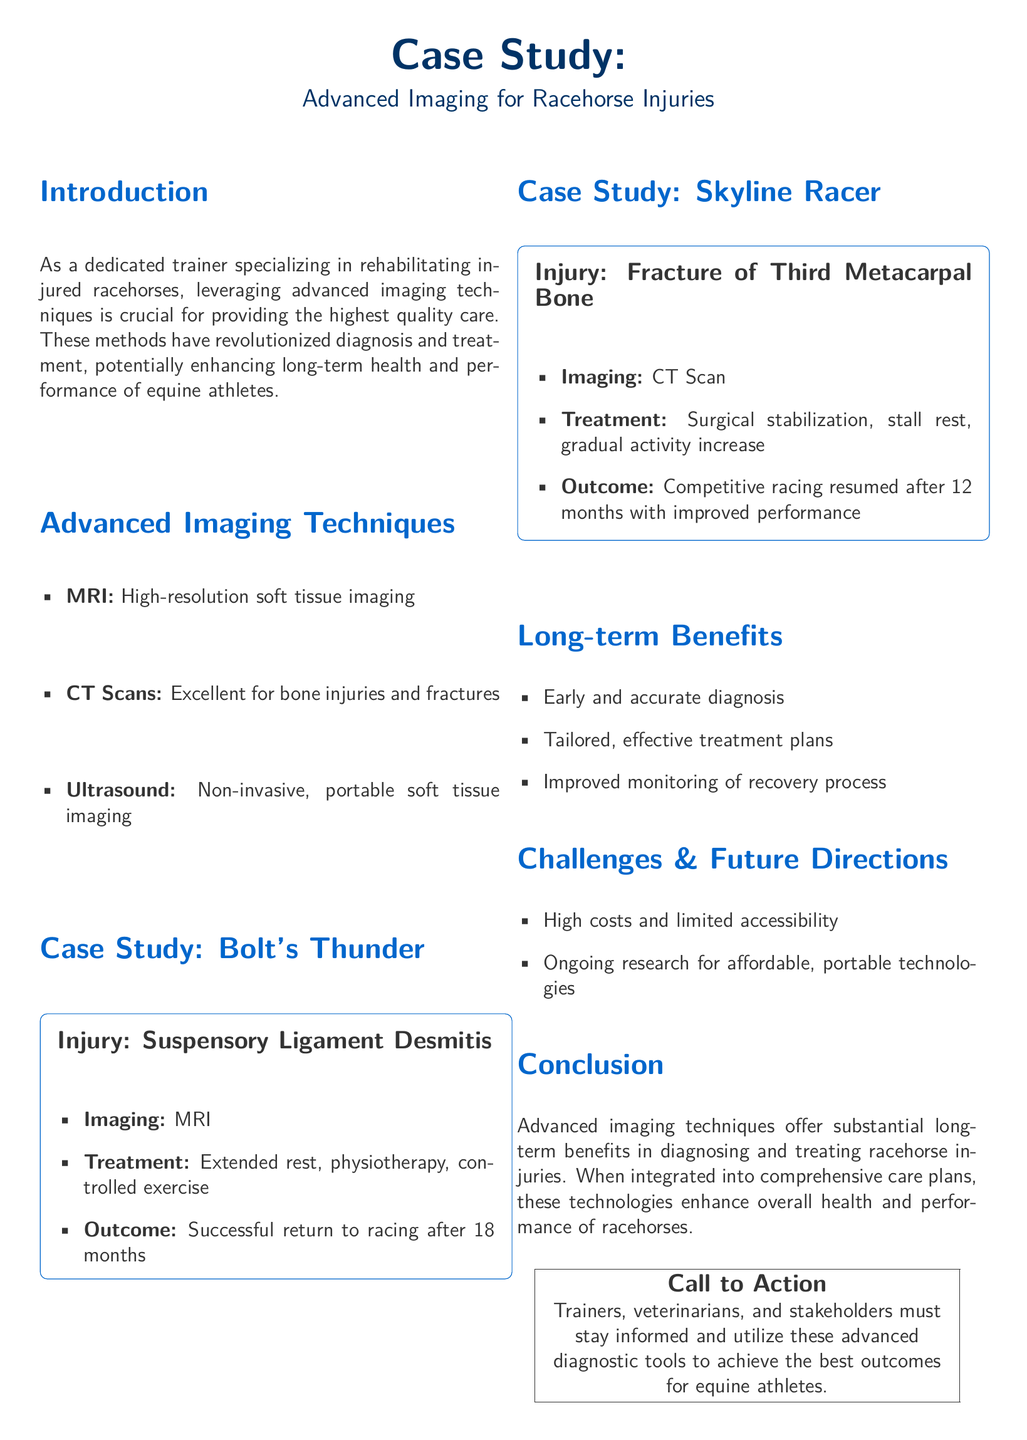What injury did Bolt's Thunder sustain? Bolt's Thunder's injury is the Suspensory Ligament Desmitis, as stated in the case study.
Answer: Suspensory Ligament Desmitis What imaging technique was used for Skyline Racer? The document specifies that a CT Scan was used for Skyline Racer's injury.
Answer: CT Scan How long was Bolt's Thunder's recovery period? The document provides that the recovery period for Bolt's Thunder was 18 months.
Answer: 18 months What is one of the long-term benefits of advanced imaging techniques? The long-term benefits listed include early and accurate diagnosis, tailored treatment plans, and improved monitoring.
Answer: Early and accurate diagnosis What challenge related to advanced imaging is mentioned in the document? The document highlights high costs and limited accessibility as a challenge to using advanced imaging techniques.
Answer: High costs What treatment was used for Skyline Racer? According to the document, the treatment for Skyline Racer included surgical stabilization, stall rest, and gradual activity increase.
Answer: Surgical stabilization What did the case studies illustrate about the outcomes of using advanced imaging? The case studies showed successful outcomes for both racehorses, with Bolt's Thunder returning to racing and Skyline Racer resuming competitive racing.
Answer: Successful outcomes What is the main call to action for trainers mentioned in the conclusion? The call to action emphasizes the importance of trainers, veterinarians, and stakeholders staying informed about advanced diagnostic tools.
Answer: Stay informed 